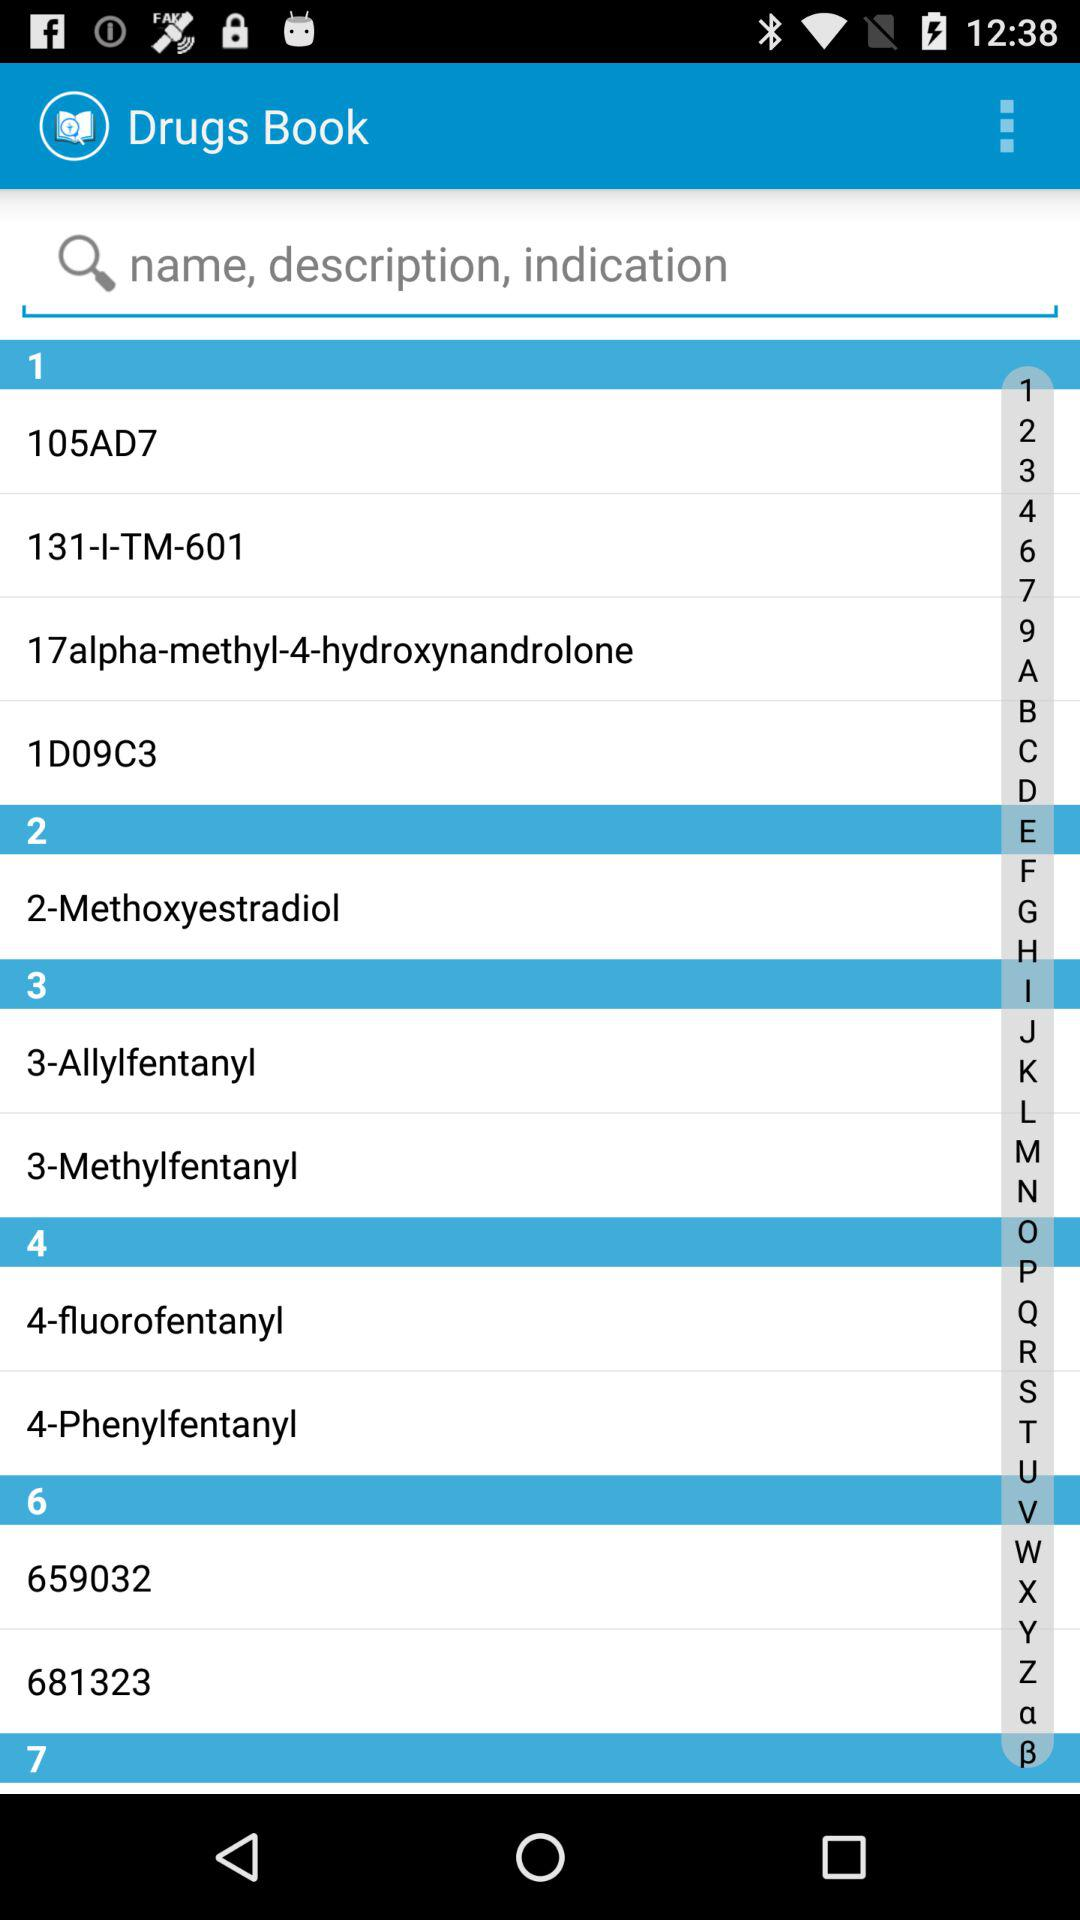What is the application name? The application name is "Drugs Book". 